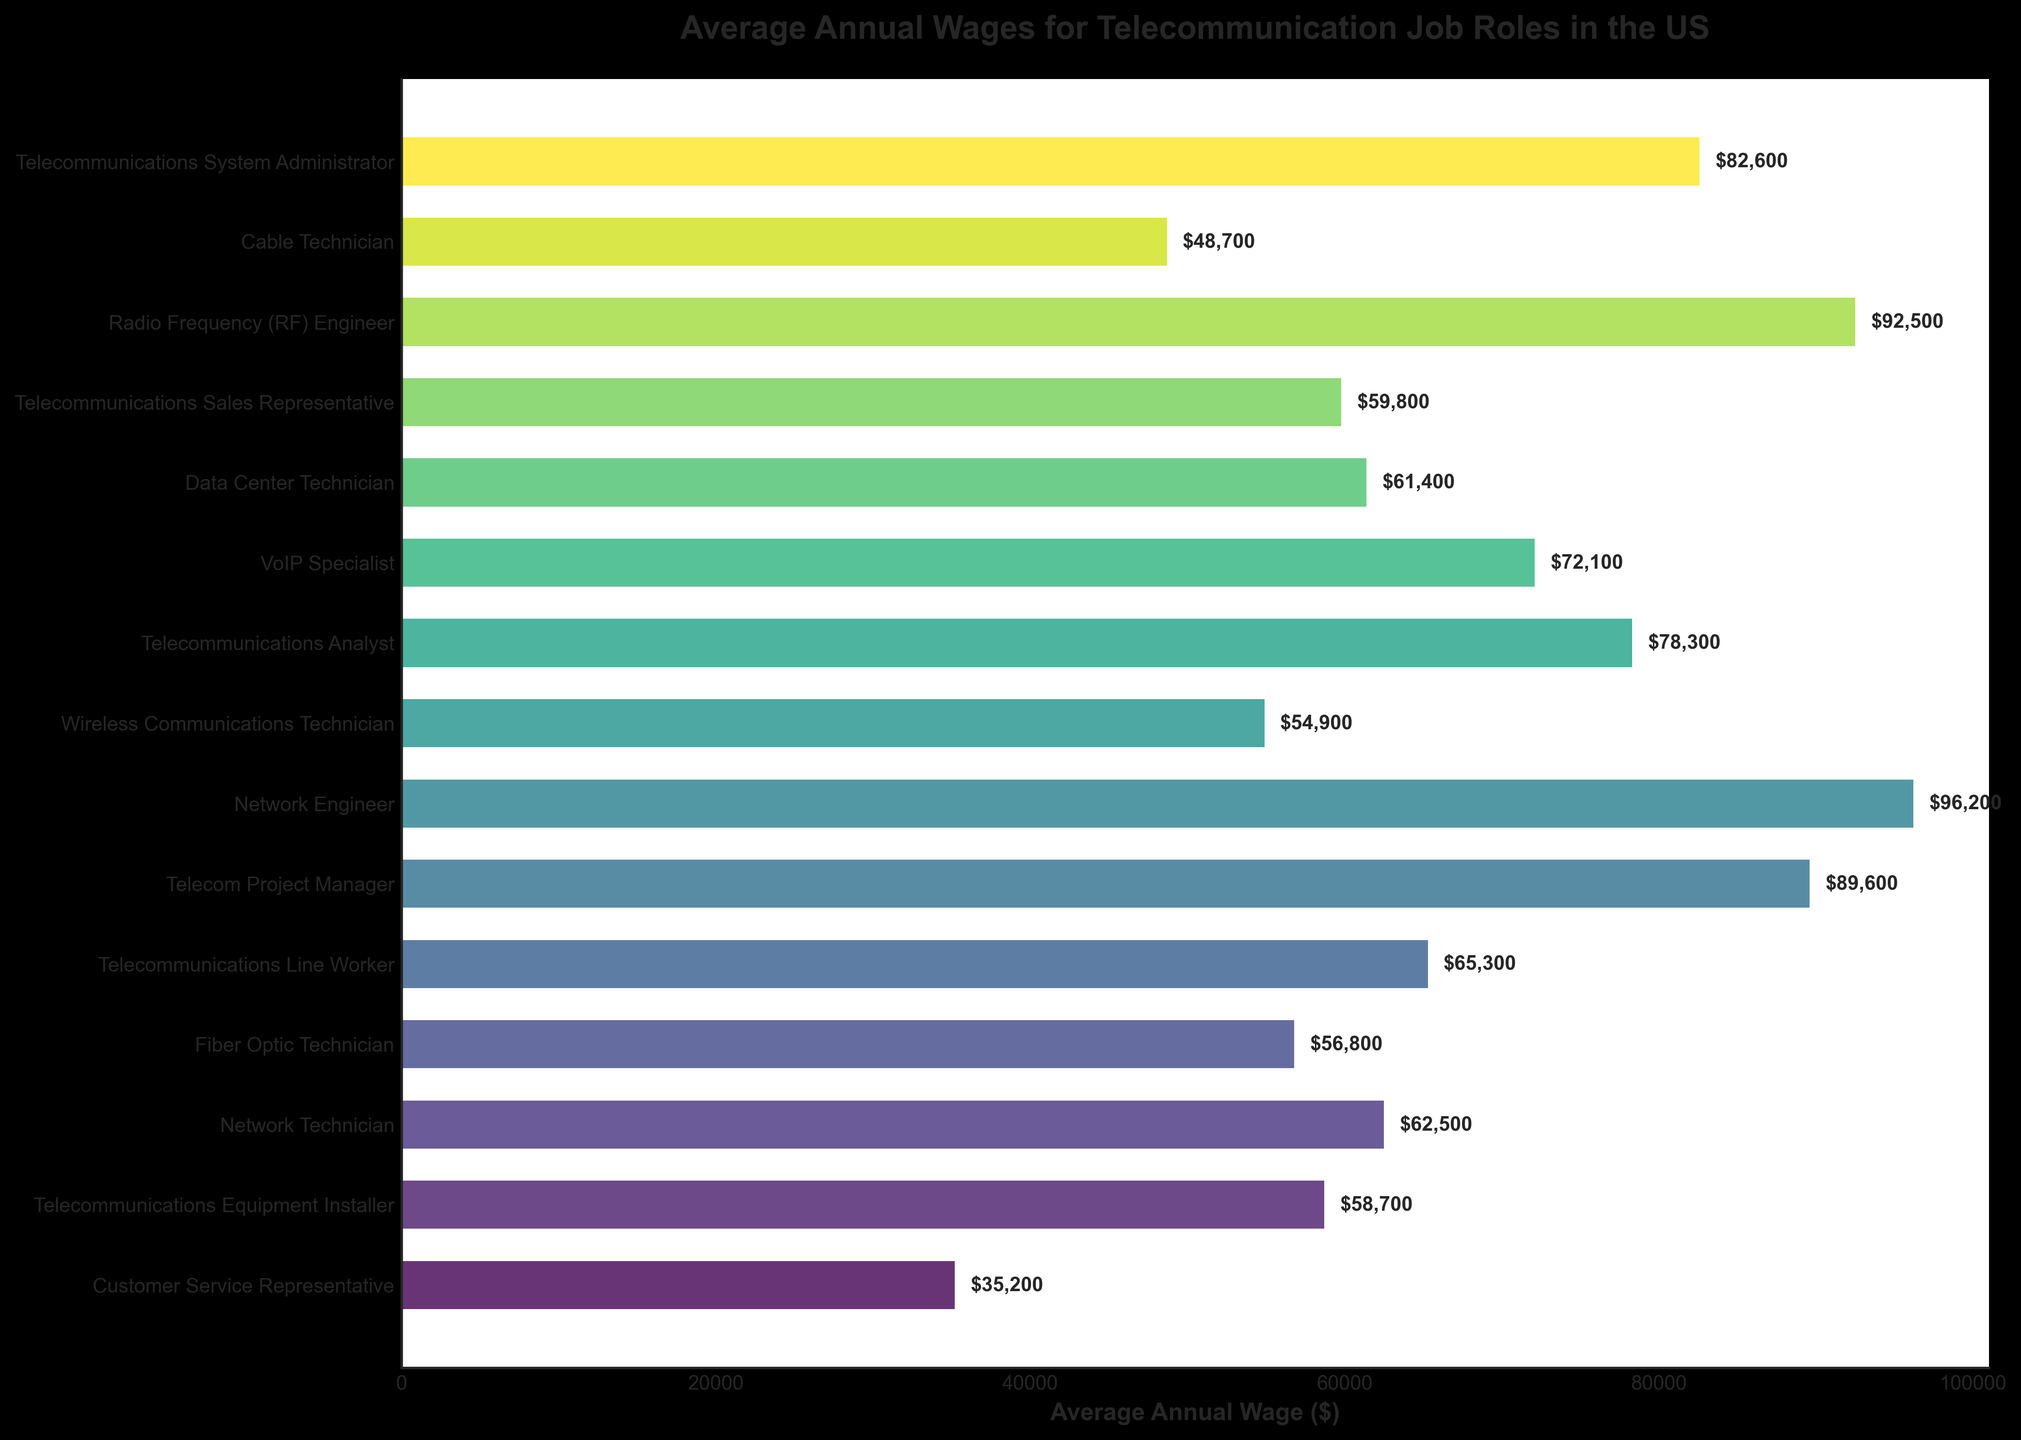What's the highest paying job role in the figure? We observe the lengths of the bars on the horizontal axis. The longest bar indicates the highest value, which is for the Network Engineer with an average annual wage of $96,200.
Answer: Network Engineer Which job role pays more, a Fiber Optic Technician or a VoIP Specialist? Compare the lengths of the bars for the Fiber Optic Technician and VoIP Specialist. The bar for VoIP Specialist is longer, indicating a higher wage of $72,100 compared to $56,800 for the Fiber Optic Technician.
Answer: VoIP Specialist What is the average annual wage of a Data Center Technician and a Telecommunications Sales Representative? Sum the wages of Data Center Technician ($61,400) and Telecommunications Sales Representative ($59,800) which is $61,400 + $59,800 = $121,200. Then, divide by 2 to get the average: $121,200 / 2 = $60,600.
Answer: $60,600 Which job roles have an average annual wage above $85,000? Identify the bars that extend beyond the $85,000 mark on the horizontal axis. These roles are Telecom Project Manager ($89,600), Network Engineer ($96,200), and Radio Frequency (RF) Engineer ($92,500).
Answer: Telecom Project Manager, Network Engineer, Radio Frequency (RF) Engineer How much more does a Telecommunications System Administrator earn annually compared to a Telecommunications Equipment Installer? Determine the wages for both roles: Telecommunications System Administrator ($82,600) and Telecommunications Equipment Installer ($58,700). Calculate the difference: $82,600 - $58,700 = $23,900.
Answer: $23,900 What is the range of average annual wages for the job roles? Determine the highest wage, $96,200 for Network Engineer, and the lowest wage, $35,200 for Customer Service Representative. Calculate the range: $96,200 - $35,200 = $61,000.
Answer: $61,000 Which job roles fall in the middle half of the wage distribution, between the 25th and 75th percentiles? To find the interquartile range, sort all wages and identify the middle half. Calculating 25th and 75th percentiles from wages: sorted values are $35,200, $48,700, $54,900, $56,800, $58,700, $59,800, $61,400, $62,500, $65,300, $72,100, $78,300, $82,600, $89,600, $92,500, $96,200. Therefore, the middle half is between the 25th ($54,900) and 75th percentiles ($82,600). Job roles: Wireless Communications Technician, Fiber Optic Technician, Telecommunications Equipment Installer, Telecommunications Sales Representative, Data Center Technician, Network Technician, Telecommunications Line Worker, VoIP Specialist, Telecommunications Analyst, and Telecommunications System Administrator.
Answer: Wireless Communications Technician, Fiber Optic Technician, Telecommunications Equipment Installer, Telecommunications Sales Representative, Data Center Technician, Network Technician, Telecommunications Line Worker, VoIP Specialist, Telecommunications Analyst, Telecommunications System Administrator 